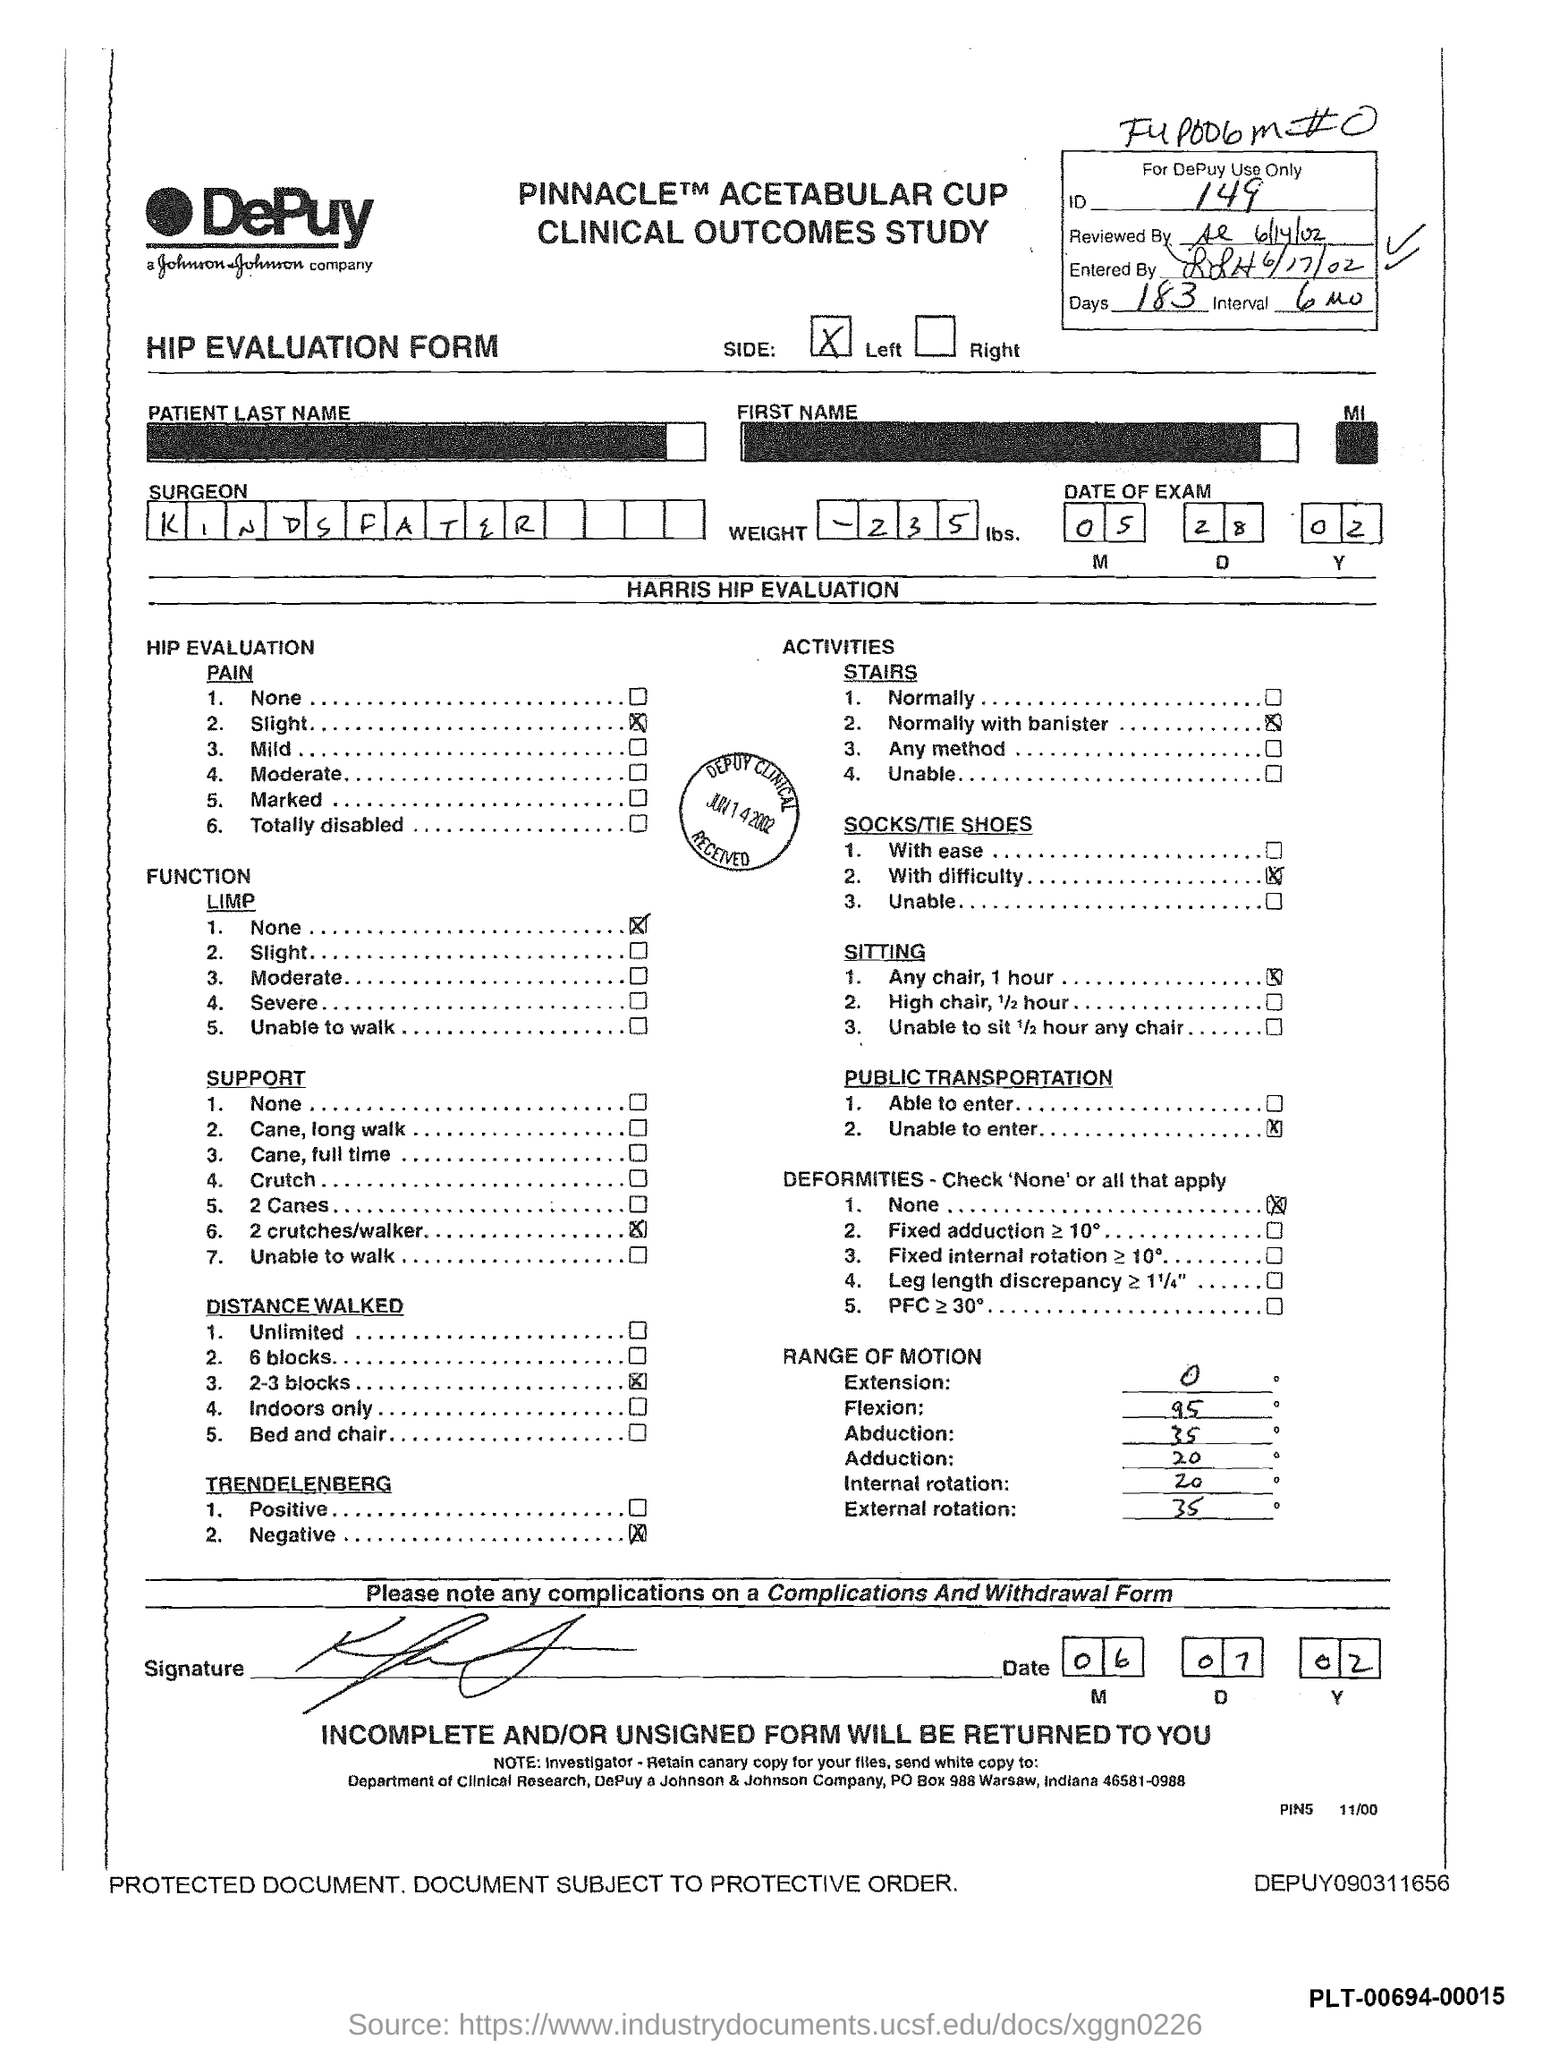What is the date of the exam ? ( m   d   y )
Your answer should be very brief. 05   28   02. What is the weight mentioned ?
Your response must be concise. -235 lbs. What is the name of the company
Provide a short and direct response. Depuy  johnson johnson company. What is the id mentioned ?
Make the answer very short. 149. What is the date mentioned at the bottom of the page? ( m d y )
Ensure brevity in your answer.  06 07 02. How many days are mentioned in the form
Give a very brief answer. 183. What is the range of motion for external rotation
Your answer should be very brief. 35. What is the range of motion for extension
Your response must be concise. 0. What is the range of motion for adduction
Make the answer very short. 20. 